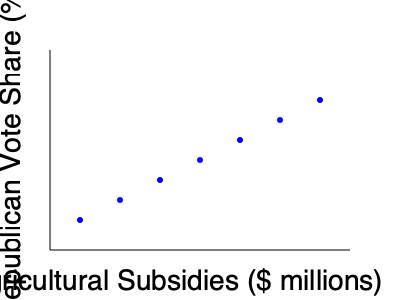As a political correspondent in Nebraska, you're analyzing the relationship between agricultural subsidies and voting patterns in rural counties. The scatter plot shows the correlation between agricultural subsidies and Republican vote share in several counties. What type of correlation does this plot suggest, and how might this inform your reporting on the political landscape in Nebraska's agricultural regions? To analyze the correlation between agricultural subsidies and Republican vote share, we need to examine the pattern in the scatter plot:

1. Observe the overall trend: As we move from left to right (increasing agricultural subsidies), the points generally move downward (decreasing Republican vote share).

2. Identify the correlation type:
   - Positive correlation: Points trend upward from left to right
   - Negative correlation: Points trend downward from left to right
   - No correlation: Points show no clear trend

3. In this case, we see a clear downward trend, indicating a negative correlation.

4. Strength of correlation:
   - The points form a fairly consistent line, suggesting a strong correlation.
   - There's little scatter or deviation from the trend.

5. Interpretation for Nebraska:
   - As agricultural subsidies increase, the Republican vote share tends to decrease.
   - This suggests that counties receiving more agricultural subsidies may be less likely to vote Republican.

6. Reporting implications:
   - This trend challenges the common assumption that rural, agricultural areas always strongly support Republicans.
   - It may indicate that farmers benefiting from subsidies are more likely to support politicians who advocate for such programs, regardless of party.
   - The correlation could reflect changing political dynamics in agricultural communities or the impact of specific policies on voting behavior.

7. Cautions for reporting:
   - Correlation does not imply causation. Other factors may influence this relationship.
   - The sample size and geographic spread of the data should be considered.
   - Historical context and recent policy changes may provide additional insights.
Answer: Strong negative correlation; suggests higher agricultural subsidies associated with lower Republican vote share in Nebraska counties, potentially indicating complex political dynamics in agricultural regions. 